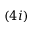Convert formula to latex. <formula><loc_0><loc_0><loc_500><loc_500>( 4 i )</formula> 